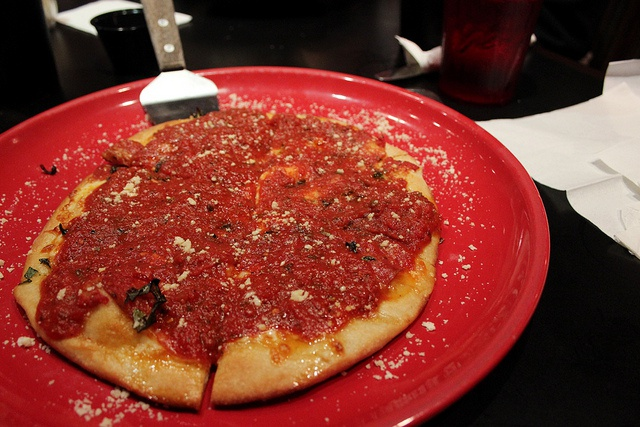Describe the objects in this image and their specific colors. I can see pizza in black, brown, maroon, and tan tones, dining table in black, maroon, brown, and darkgray tones, cup in black, maroon, gray, and brown tones, fork in black, white, and gray tones, and cup in black, ivory, gray, and darkgray tones in this image. 